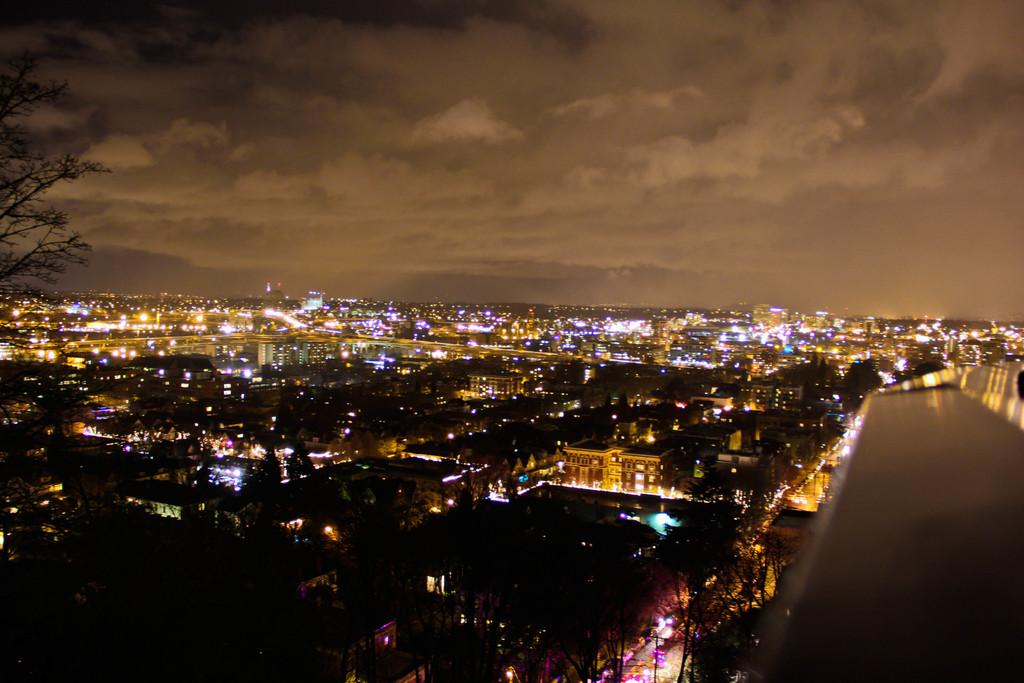What type of natural elements can be seen in the image? There are trees in the image. What type of man-made structures are present in the image? There are buildings in the image. What type of illumination is visible in the image? There are lights in the image. What can be seen in the sky at the top of the image? There are clouds in the sky at the top of the image. Where is the stove located in the image? There is no stove present in the image. Can you see any windows in the image? The provided facts do not mention any windows, so we cannot determine their presence from the image. What type of oven is visible in the image? There is no oven present in the image. 